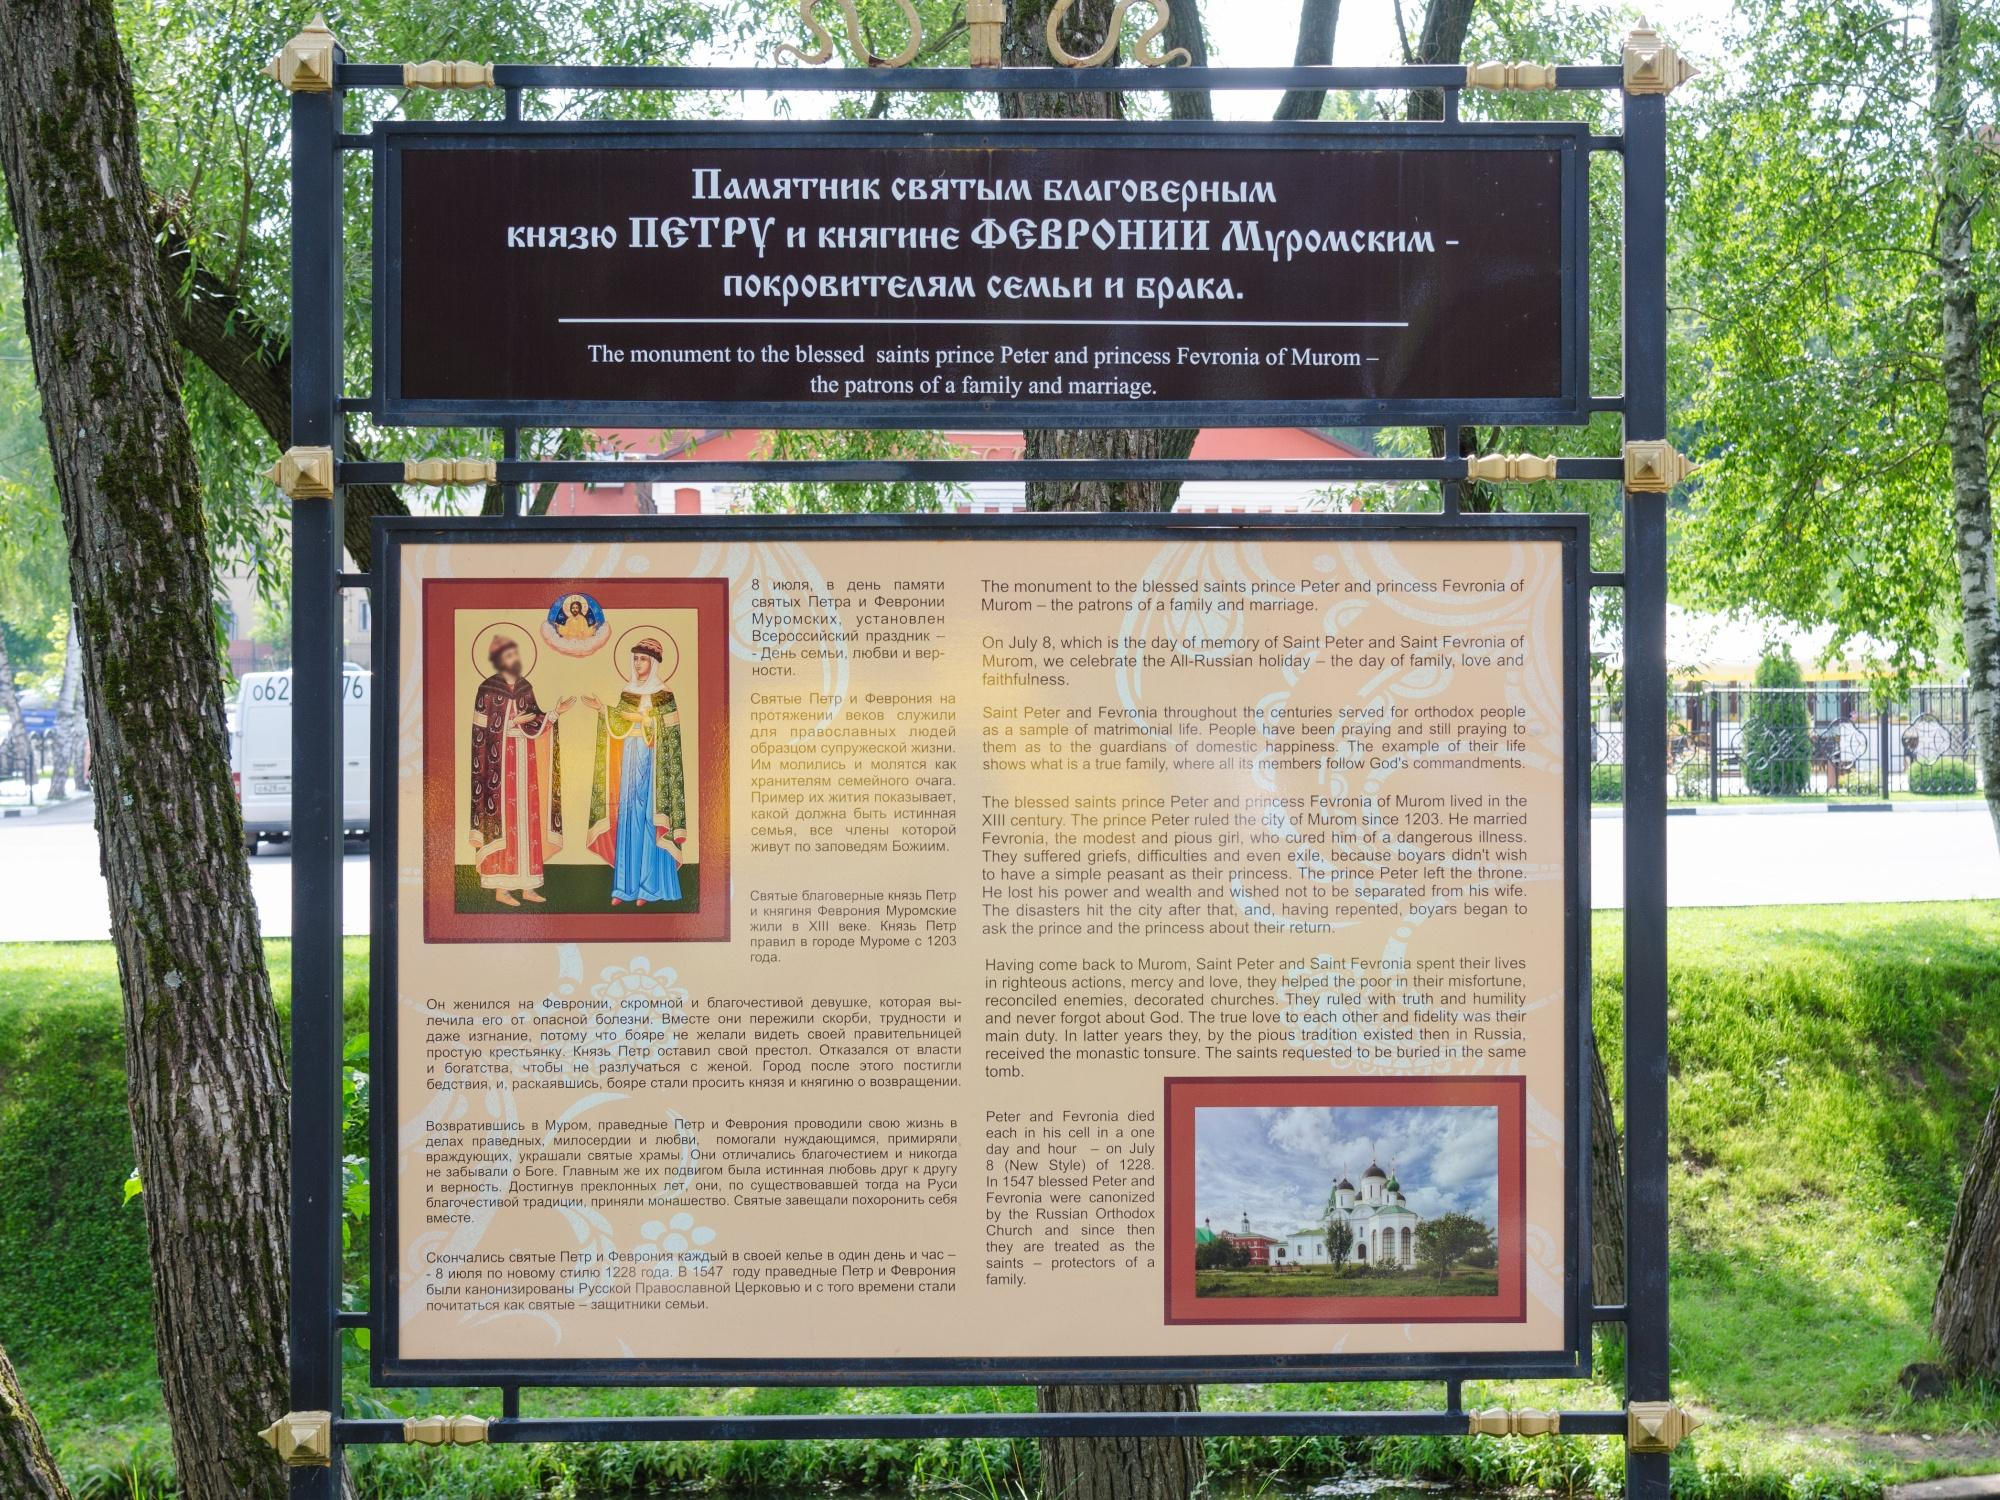What kind of reactions do you think this signboard might evoke in its viewers? This signboard is likely to evoke a sense of curiosity and appreciation among its viewers. For those familiar with Russian cultural history, it serves as a poignant reminder of the enduring values of love and fidelity represented by Prince Peter and Princess Fevronia. For visitors less familiar with the story, it might spark an interest in learning more about Russian heritage and the symbolic meanings embedded in their celebrated figures. Additionally, the tranquil setting might invoke a reflective mood, allowing viewers to contemplate the deep historical roots and the cultural significance conveyed through the signboard. 